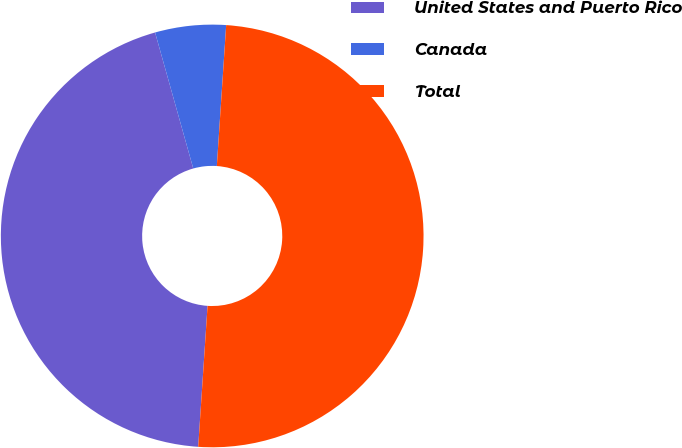<chart> <loc_0><loc_0><loc_500><loc_500><pie_chart><fcel>United States and Puerto Rico<fcel>Canada<fcel>Total<nl><fcel>44.59%<fcel>5.41%<fcel>50.0%<nl></chart> 